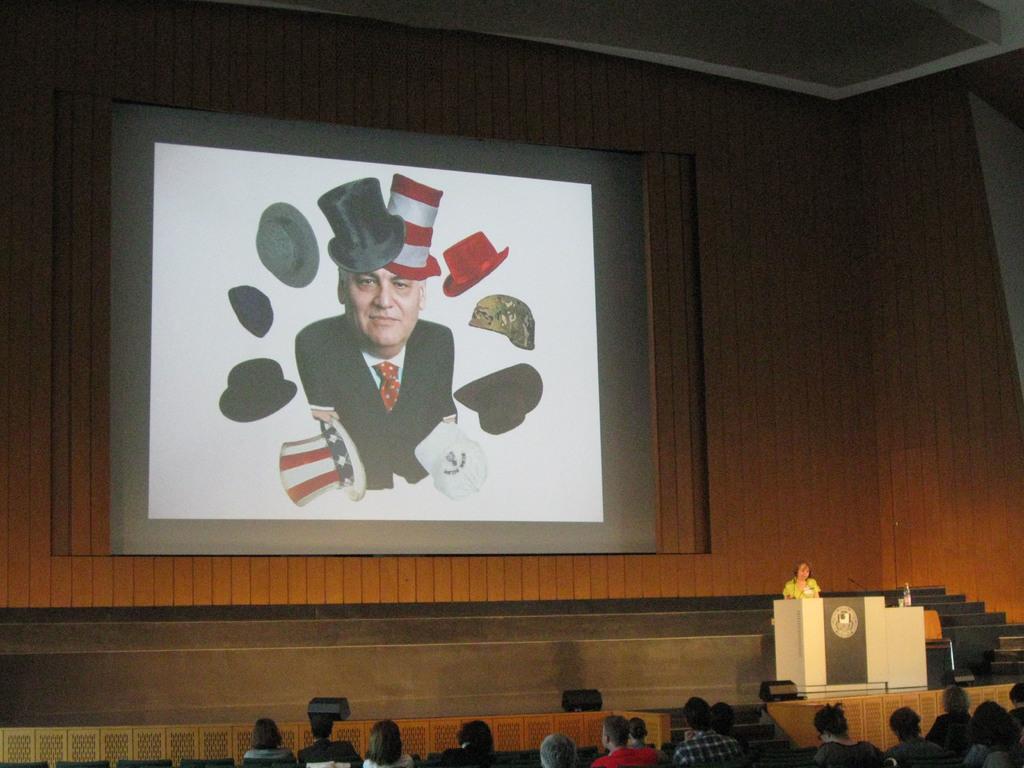Could you give a brief overview of what you see in this image? In this image there are people sitting on a chairs, in the background there is a stage, a woman standing near a podium and there is a wall, for that wall there is a screen. 